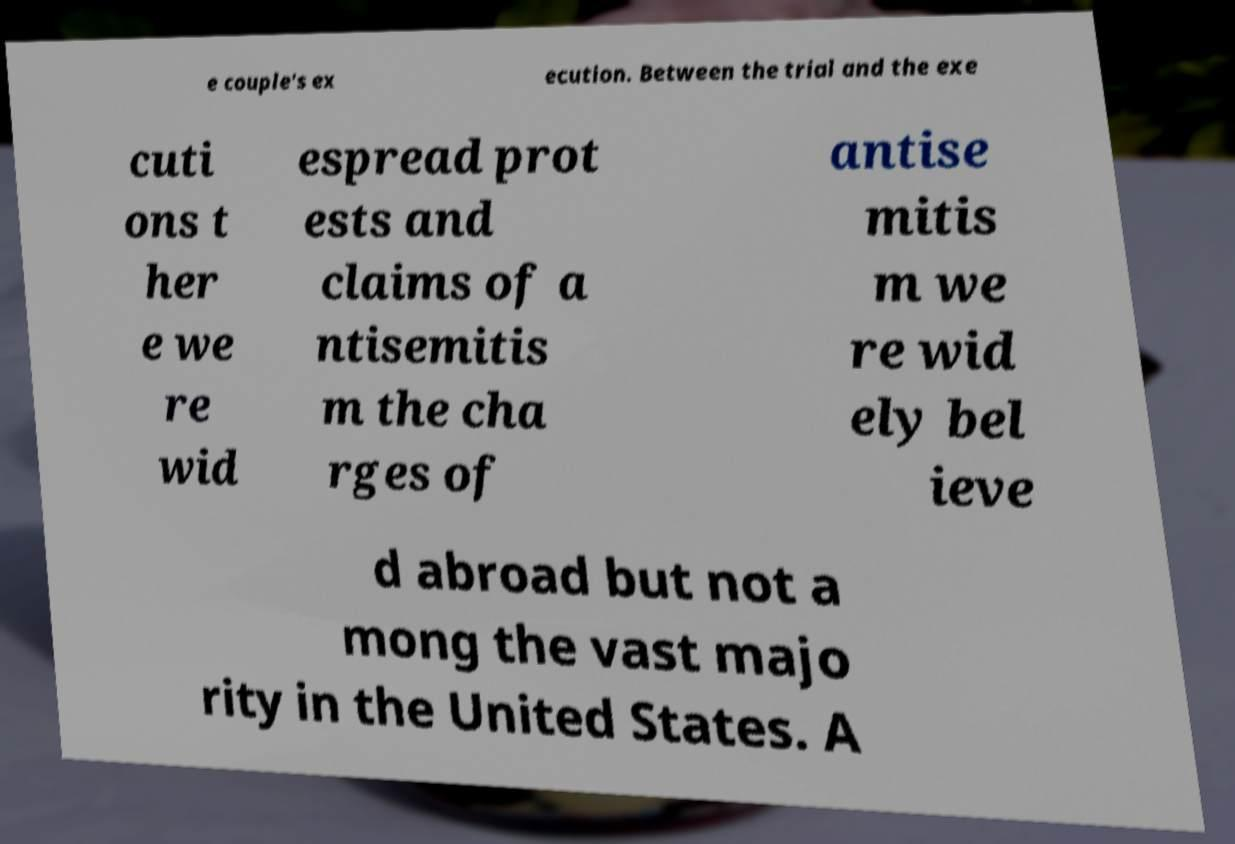I need the written content from this picture converted into text. Can you do that? e couple's ex ecution. Between the trial and the exe cuti ons t her e we re wid espread prot ests and claims of a ntisemitis m the cha rges of antise mitis m we re wid ely bel ieve d abroad but not a mong the vast majo rity in the United States. A 